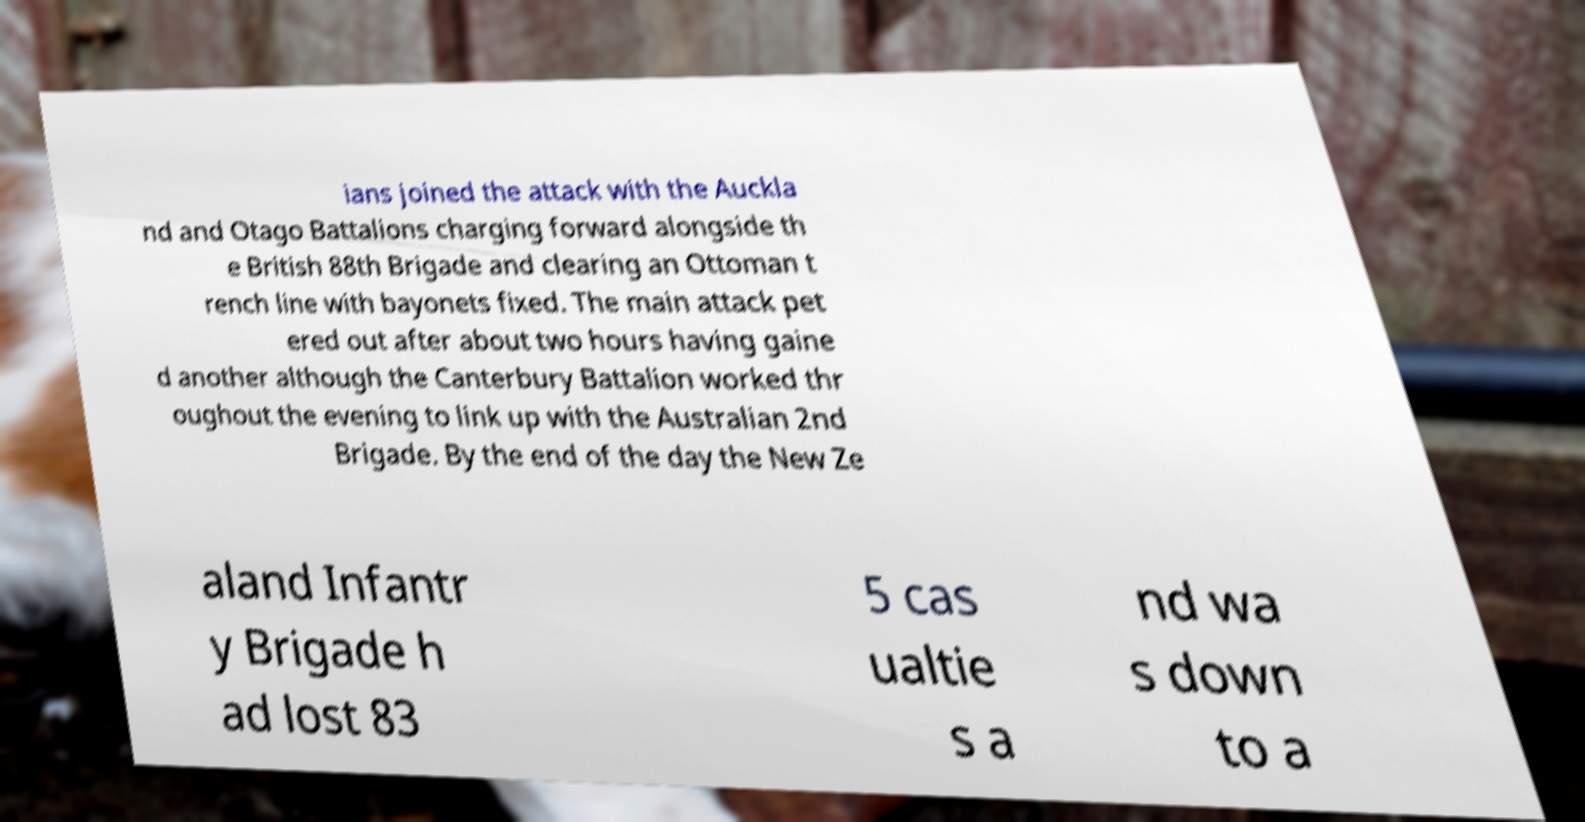I need the written content from this picture converted into text. Can you do that? ians joined the attack with the Auckla nd and Otago Battalions charging forward alongside th e British 88th Brigade and clearing an Ottoman t rench line with bayonets fixed. The main attack pet ered out after about two hours having gaine d another although the Canterbury Battalion worked thr oughout the evening to link up with the Australian 2nd Brigade. By the end of the day the New Ze aland Infantr y Brigade h ad lost 83 5 cas ualtie s a nd wa s down to a 